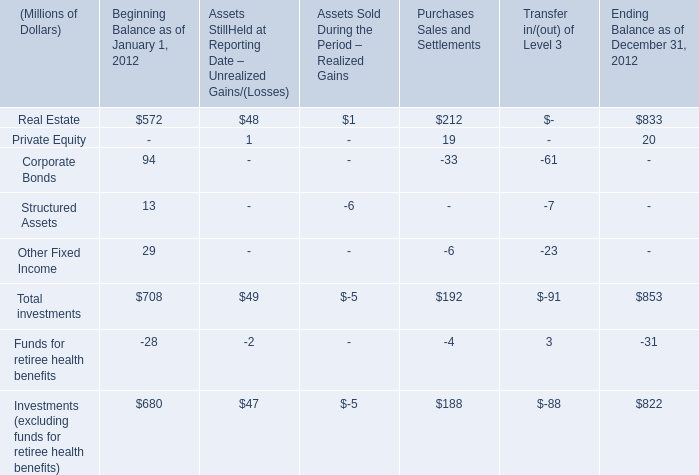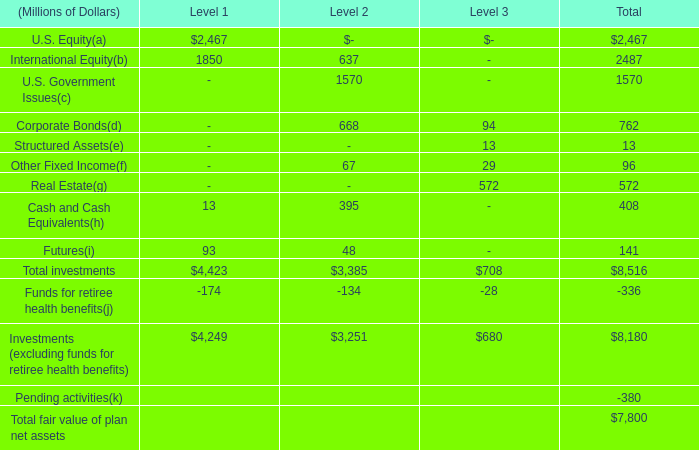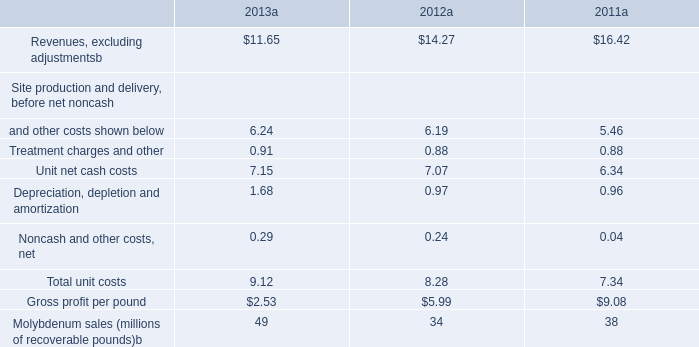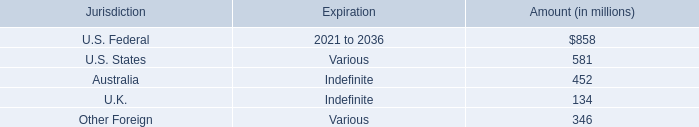What is the proportion of Other Fixed Income to the total for Total investments in terms of Beginning Balance as of January 1, 2012? 
Computations: (29 / 708)
Answer: 0.04096. 